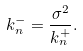Convert formula to latex. <formula><loc_0><loc_0><loc_500><loc_500>k _ { n } ^ { - } = \frac { \sigma ^ { 2 } } { k _ { n } ^ { + } } .</formula> 